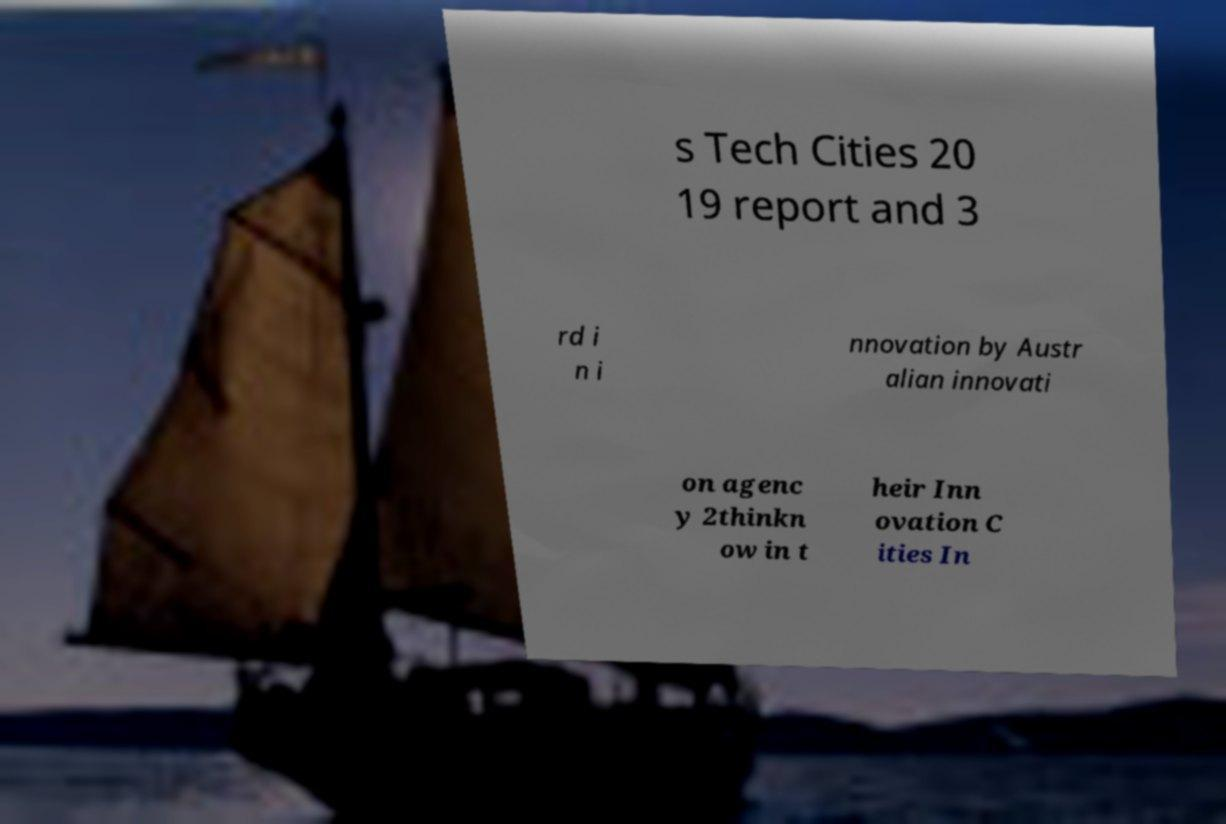Can you accurately transcribe the text from the provided image for me? s Tech Cities 20 19 report and 3 rd i n i nnovation by Austr alian innovati on agenc y 2thinkn ow in t heir Inn ovation C ities In 